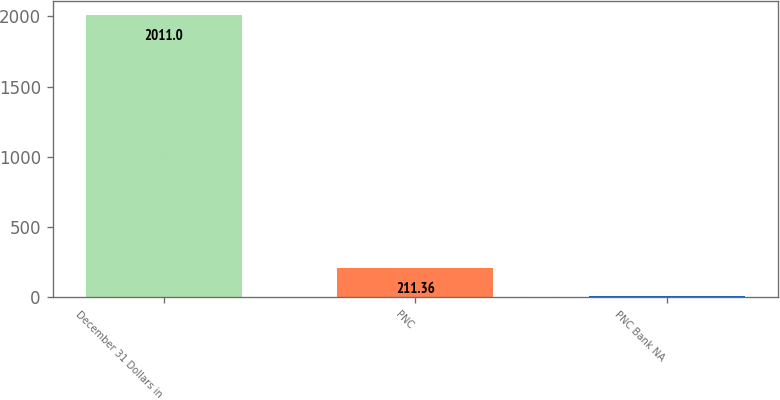<chart> <loc_0><loc_0><loc_500><loc_500><bar_chart><fcel>December 31 Dollars in<fcel>PNC<fcel>PNC Bank NA<nl><fcel>2011<fcel>211.36<fcel>11.4<nl></chart> 